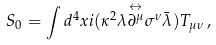<formula> <loc_0><loc_0><loc_500><loc_500>S _ { 0 } = \int d ^ { 4 } x i ( \kappa ^ { 2 } \lambda \overset { \leftrightarrow } { \partial ^ { \mu } } \sigma ^ { \nu } \bar { \lambda } ) T _ { \mu \nu } \, ,</formula> 